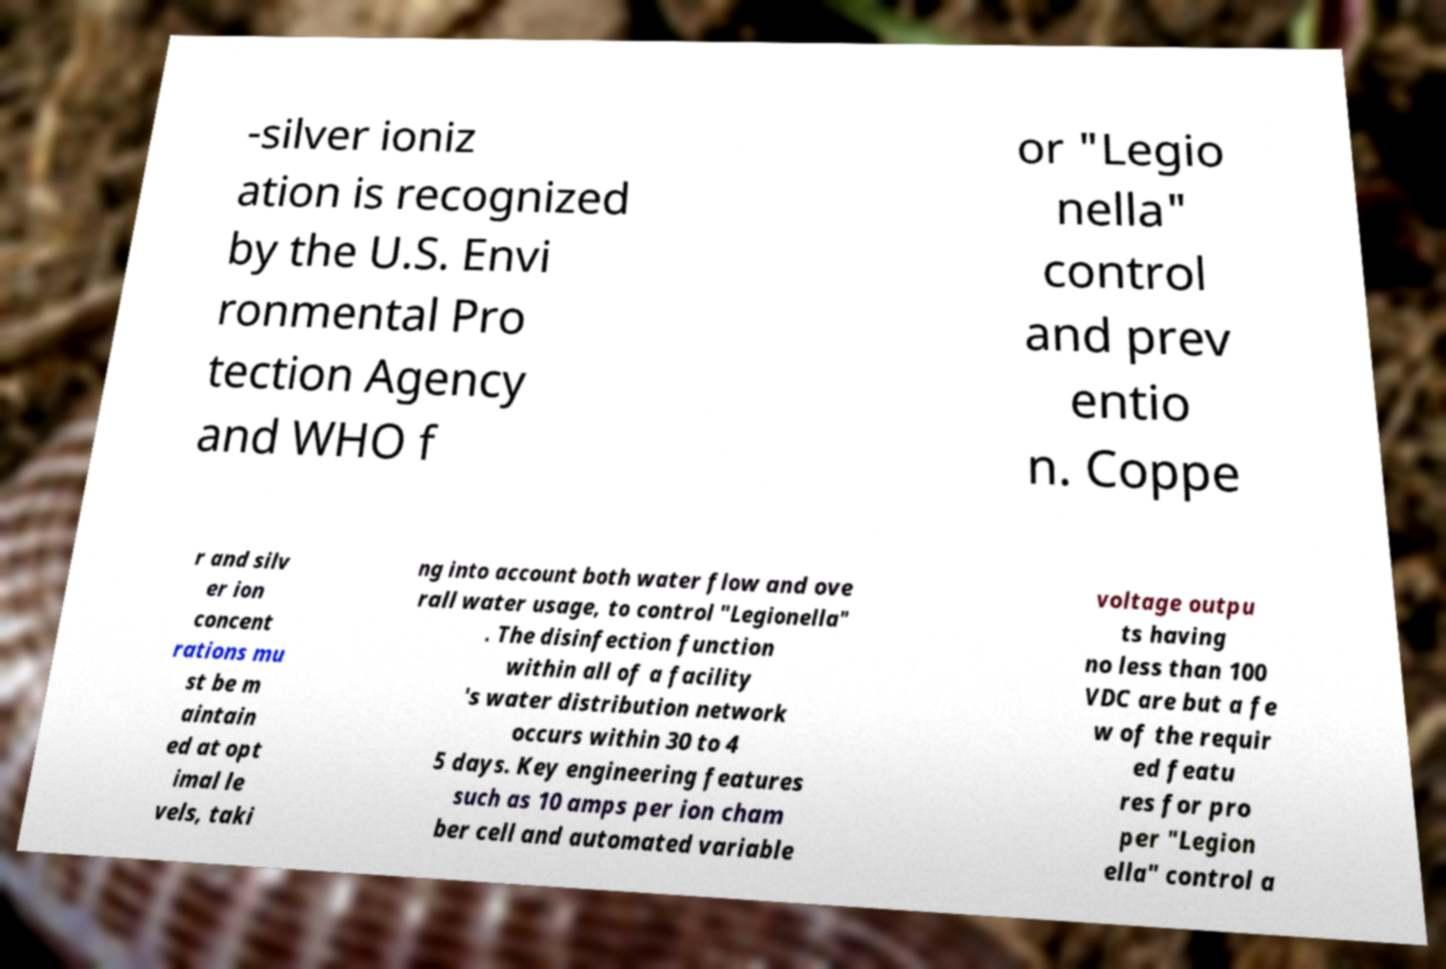Please identify and transcribe the text found in this image. -silver ioniz ation is recognized by the U.S. Envi ronmental Pro tection Agency and WHO f or "Legio nella" control and prev entio n. Coppe r and silv er ion concent rations mu st be m aintain ed at opt imal le vels, taki ng into account both water flow and ove rall water usage, to control "Legionella" . The disinfection function within all of a facility 's water distribution network occurs within 30 to 4 5 days. Key engineering features such as 10 amps per ion cham ber cell and automated variable voltage outpu ts having no less than 100 VDC are but a fe w of the requir ed featu res for pro per "Legion ella" control a 